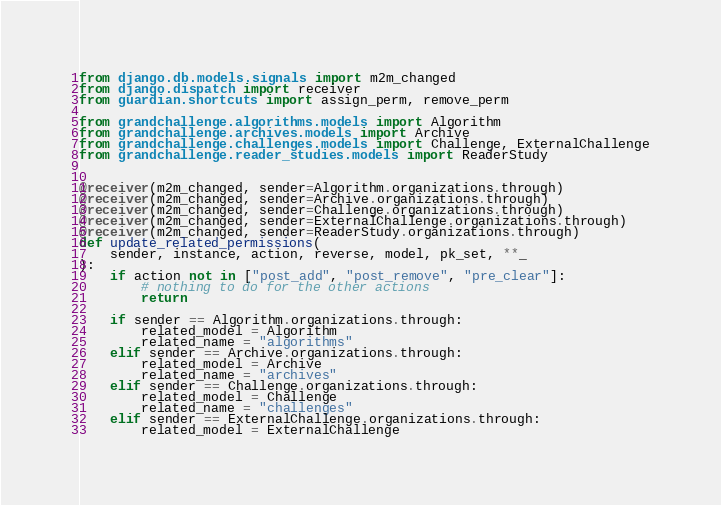<code> <loc_0><loc_0><loc_500><loc_500><_Python_>from django.db.models.signals import m2m_changed
from django.dispatch import receiver
from guardian.shortcuts import assign_perm, remove_perm

from grandchallenge.algorithms.models import Algorithm
from grandchallenge.archives.models import Archive
from grandchallenge.challenges.models import Challenge, ExternalChallenge
from grandchallenge.reader_studies.models import ReaderStudy


@receiver(m2m_changed, sender=Algorithm.organizations.through)
@receiver(m2m_changed, sender=Archive.organizations.through)
@receiver(m2m_changed, sender=Challenge.organizations.through)
@receiver(m2m_changed, sender=ExternalChallenge.organizations.through)
@receiver(m2m_changed, sender=ReaderStudy.organizations.through)
def update_related_permissions(
    sender, instance, action, reverse, model, pk_set, **_
):
    if action not in ["post_add", "post_remove", "pre_clear"]:
        # nothing to do for the other actions
        return

    if sender == Algorithm.organizations.through:
        related_model = Algorithm
        related_name = "algorithms"
    elif sender == Archive.organizations.through:
        related_model = Archive
        related_name = "archives"
    elif sender == Challenge.organizations.through:
        related_model = Challenge
        related_name = "challenges"
    elif sender == ExternalChallenge.organizations.through:
        related_model = ExternalChallenge</code> 